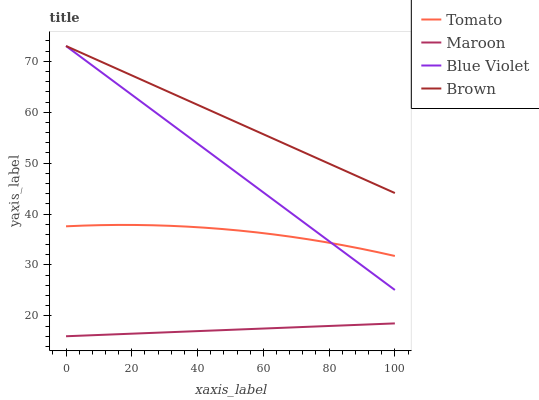Does Blue Violet have the minimum area under the curve?
Answer yes or no. No. Does Blue Violet have the maximum area under the curve?
Answer yes or no. No. Is Brown the smoothest?
Answer yes or no. No. Is Brown the roughest?
Answer yes or no. No. Does Blue Violet have the lowest value?
Answer yes or no. No. Does Maroon have the highest value?
Answer yes or no. No. Is Maroon less than Blue Violet?
Answer yes or no. Yes. Is Blue Violet greater than Maroon?
Answer yes or no. Yes. Does Maroon intersect Blue Violet?
Answer yes or no. No. 